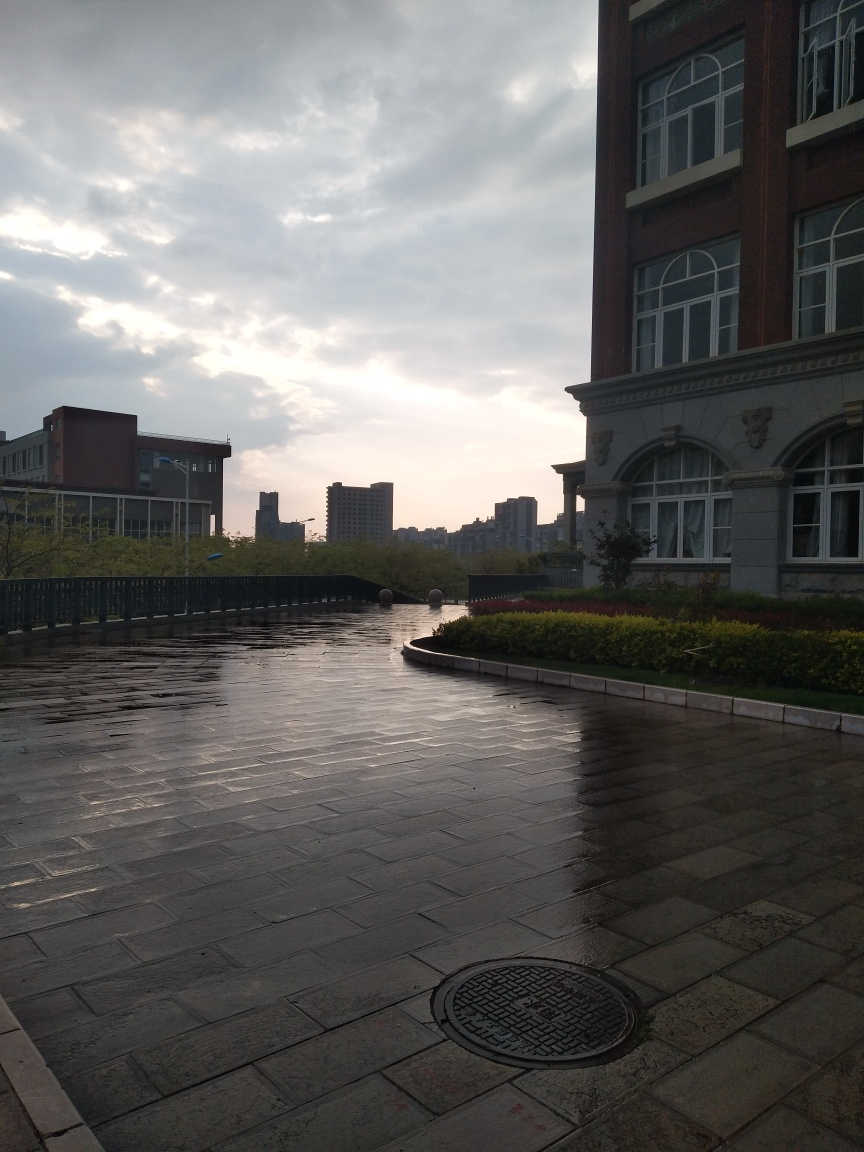What can you tell me about the architecture in the image? The architecture in the image suggests a blend of modernity and classic design. The prominent building in the center has large windows and a traditional architectural style with ornate detailing and symmetry. Meanwhile, the surrounding structures have simpler lines, indicative of more contemporary design. 